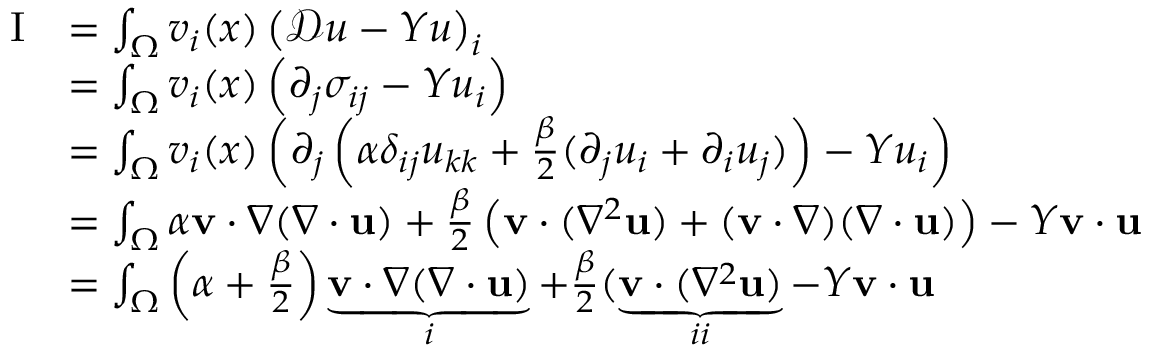<formula> <loc_0><loc_0><loc_500><loc_500>\begin{array} { r l } { I } & { = \int _ { \Omega } v _ { i } ( x ) \left ( \mathcal { D } u - Y u \right ) _ { i } } \\ & { = \int _ { \Omega } v _ { i } ( x ) \left ( \partial _ { j } \sigma _ { i j } - Y u _ { i } \right ) } \\ & { = \int _ { \Omega } v _ { i } ( x ) \left ( \partial _ { j } \left ( \alpha \delta _ { i j } u _ { k k } + \frac { \beta } { 2 } ( \partial _ { j } u _ { i } + \partial _ { i } u _ { j } ) \right ) - Y u _ { i } \right ) } \\ & { = \int _ { \Omega } \alpha v \cdot \nabla ( \nabla \cdot u ) + \frac { \beta } { 2 } \left ( v \cdot ( \nabla ^ { 2 } u ) + ( v \cdot \nabla ) ( \nabla \cdot u ) \right ) - Y v \cdot u } \\ & { = \int _ { \Omega } \left ( \alpha + \frac { \beta } { 2 } \right ) \underbrace { v \cdot \nabla ( \nabla \cdot u ) } _ { i } + \frac { \beta } { 2 } ( \underbrace { v \cdot ( \nabla ^ { 2 } u ) } _ { i i } - Y v \cdot u } \end{array}</formula> 